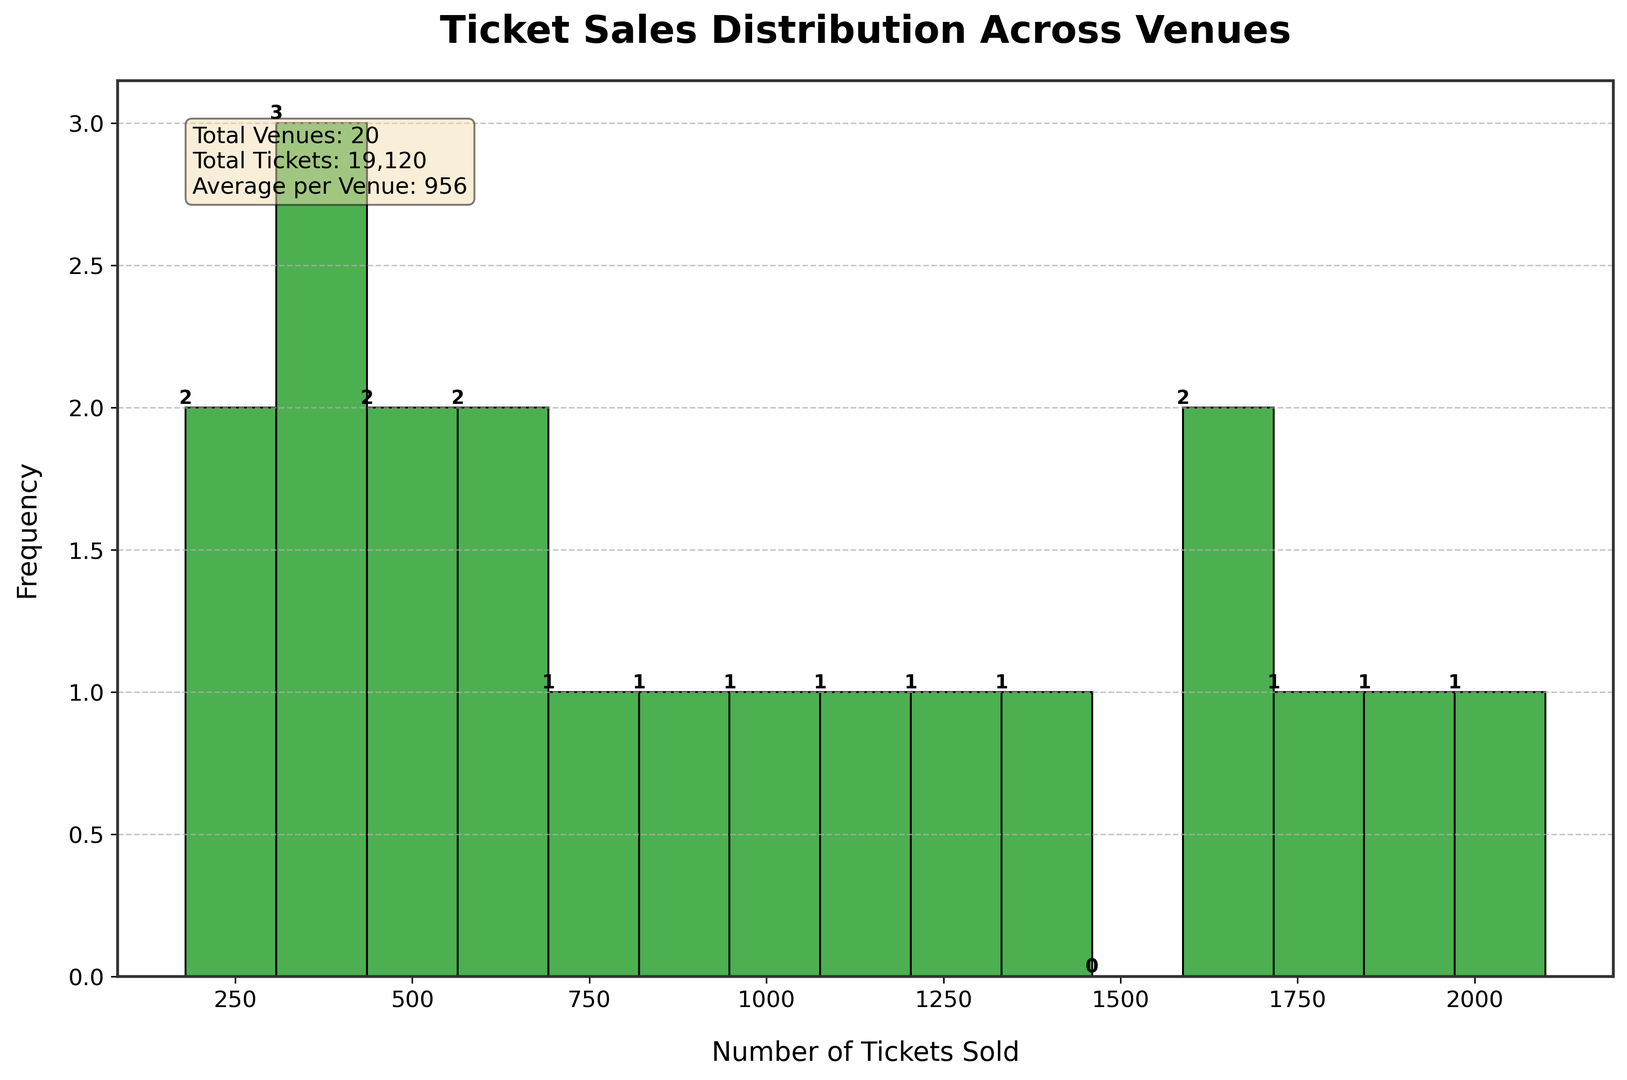What is the range of ticket sales in this distribution? To find the range, identify the minimum and maximum number of tickets sold. The minimum is 180, and the maximum is 2100. The range is then calculated as 2100 - 180.
Answer: 1920 How many venues sold between 1000 and 2000 tickets? Identify the bars on the histogram that fall between 1000 and 2000 tickets and count them. From the plot, there are 9 venues in this range.
Answer: 9 Which venue has the highest number of ticket sales, and what is the value? Look at the highest bar on the histogram and find its corresponding ticket sales value. The highest value is 2100.
Answer: Outdoor Amphitheater, 2100 How many venues sold fewer than 500 tickets? Identify the bars on the histogram that fall below 500 tickets and count them. From the plot, there are 4 venues in this range.
Answer: 4 What is the average number of tickets sold per venue? Refer to the text box in the plot which includes summary statistics. The average is already calculated as 1064 tickets per venue.
Answer: 1064 Compare the ticket sales of the highest and lowest venues. What is the difference? Identify the highest (2100) and lowest (180) ticket sales values from the histogram. The difference is calculated as 2100 - 180.
Answer: 1920 What is the median ticket sales value for the venues? To find the median, list all ticket sales numbers in order and find the middle value. With 20 values, the middle is the average of the 10th and 11th values sorted in ascending order: (890 + 980)/2.
Answer: 935 Which range of ticket sales has the highest frequency, and what is the frequency? Look at the histogram and find the range with the tallest bar. The range with the highest frequency and its corresponding frequency should be noted from the axis values and bars. The highest frequency bar corresponds to 1600-1700 range with a frequency of 2.
Answer: 1600-1700, 2 